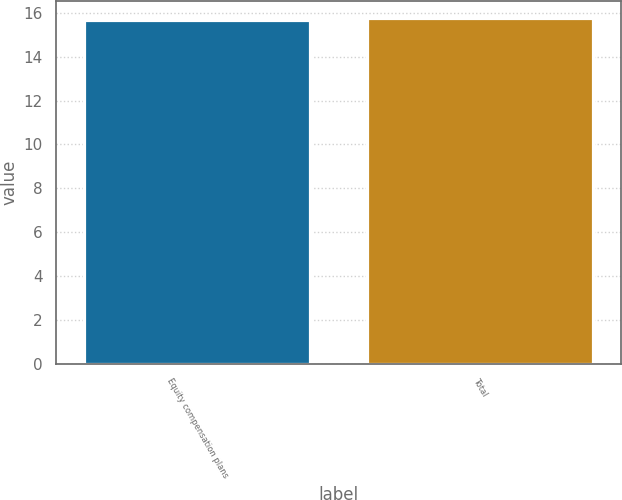Convert chart. <chart><loc_0><loc_0><loc_500><loc_500><bar_chart><fcel>Equity compensation plans<fcel>Total<nl><fcel>15.67<fcel>15.77<nl></chart> 